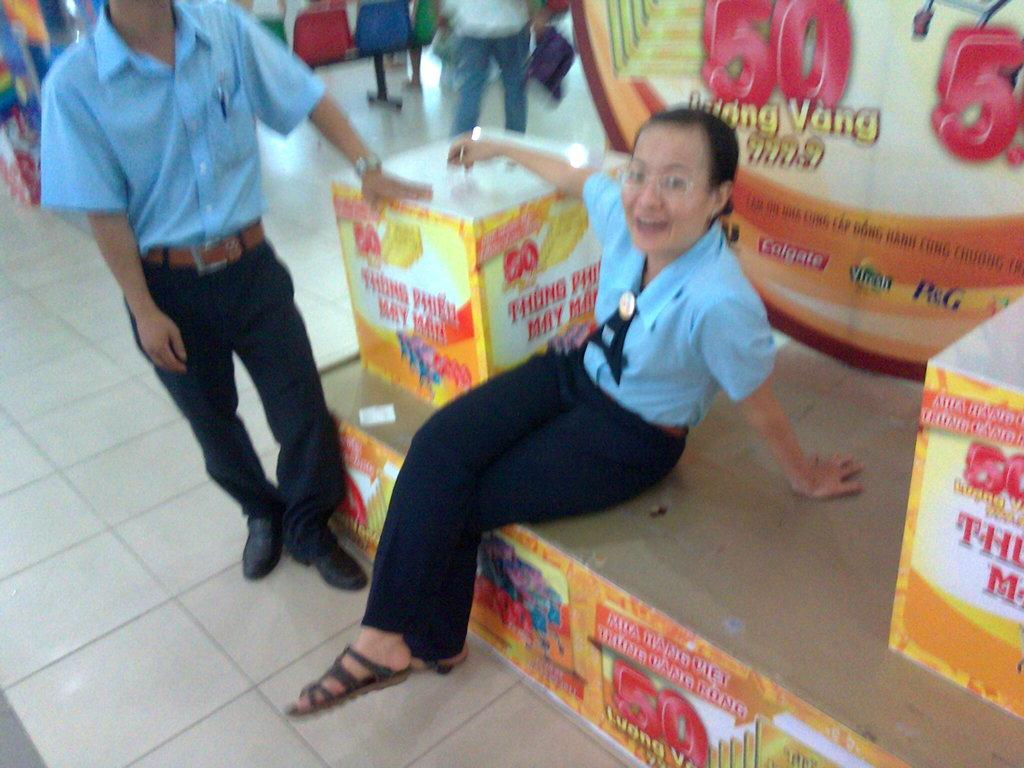Who is present in the image? There are people in the image. What is the lady doing in the image? A lady is sitting on an object in the image. What can be seen on the banner in the image? There is a banner with text in the image. What type of furniture is present in the image? There are chairs in the image. How many frogs are sitting on the chairs in the image? There are no frogs present in the image; only people are visible. What type of print can be seen on the lady's dress in the image? There is no information about the lady's dress or any prints in the provided facts. 